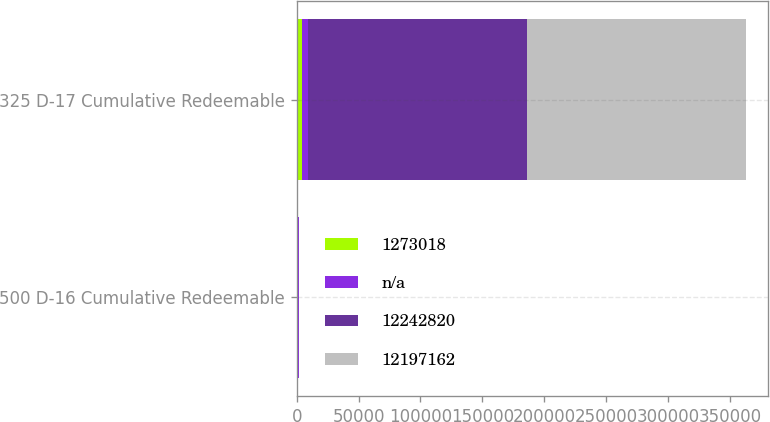Convert chart to OTSL. <chart><loc_0><loc_0><loc_500><loc_500><stacked_bar_chart><ecel><fcel>500 D-16 Cumulative Redeemable<fcel>325 D-17 Cumulative Redeemable<nl><fcel>1.27302e+06<fcel>1000<fcel>4428<nl><fcel>nan<fcel>1000<fcel>4428<nl><fcel>1.22428e+07<fcel>1<fcel>177100<nl><fcel>1.21972e+07<fcel>1<fcel>177100<nl></chart> 